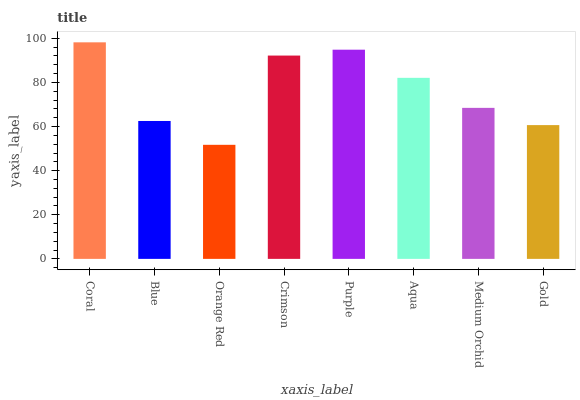Is Blue the minimum?
Answer yes or no. No. Is Blue the maximum?
Answer yes or no. No. Is Coral greater than Blue?
Answer yes or no. Yes. Is Blue less than Coral?
Answer yes or no. Yes. Is Blue greater than Coral?
Answer yes or no. No. Is Coral less than Blue?
Answer yes or no. No. Is Aqua the high median?
Answer yes or no. Yes. Is Medium Orchid the low median?
Answer yes or no. Yes. Is Coral the high median?
Answer yes or no. No. Is Coral the low median?
Answer yes or no. No. 